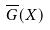Convert formula to latex. <formula><loc_0><loc_0><loc_500><loc_500>\overline { G } ( X )</formula> 